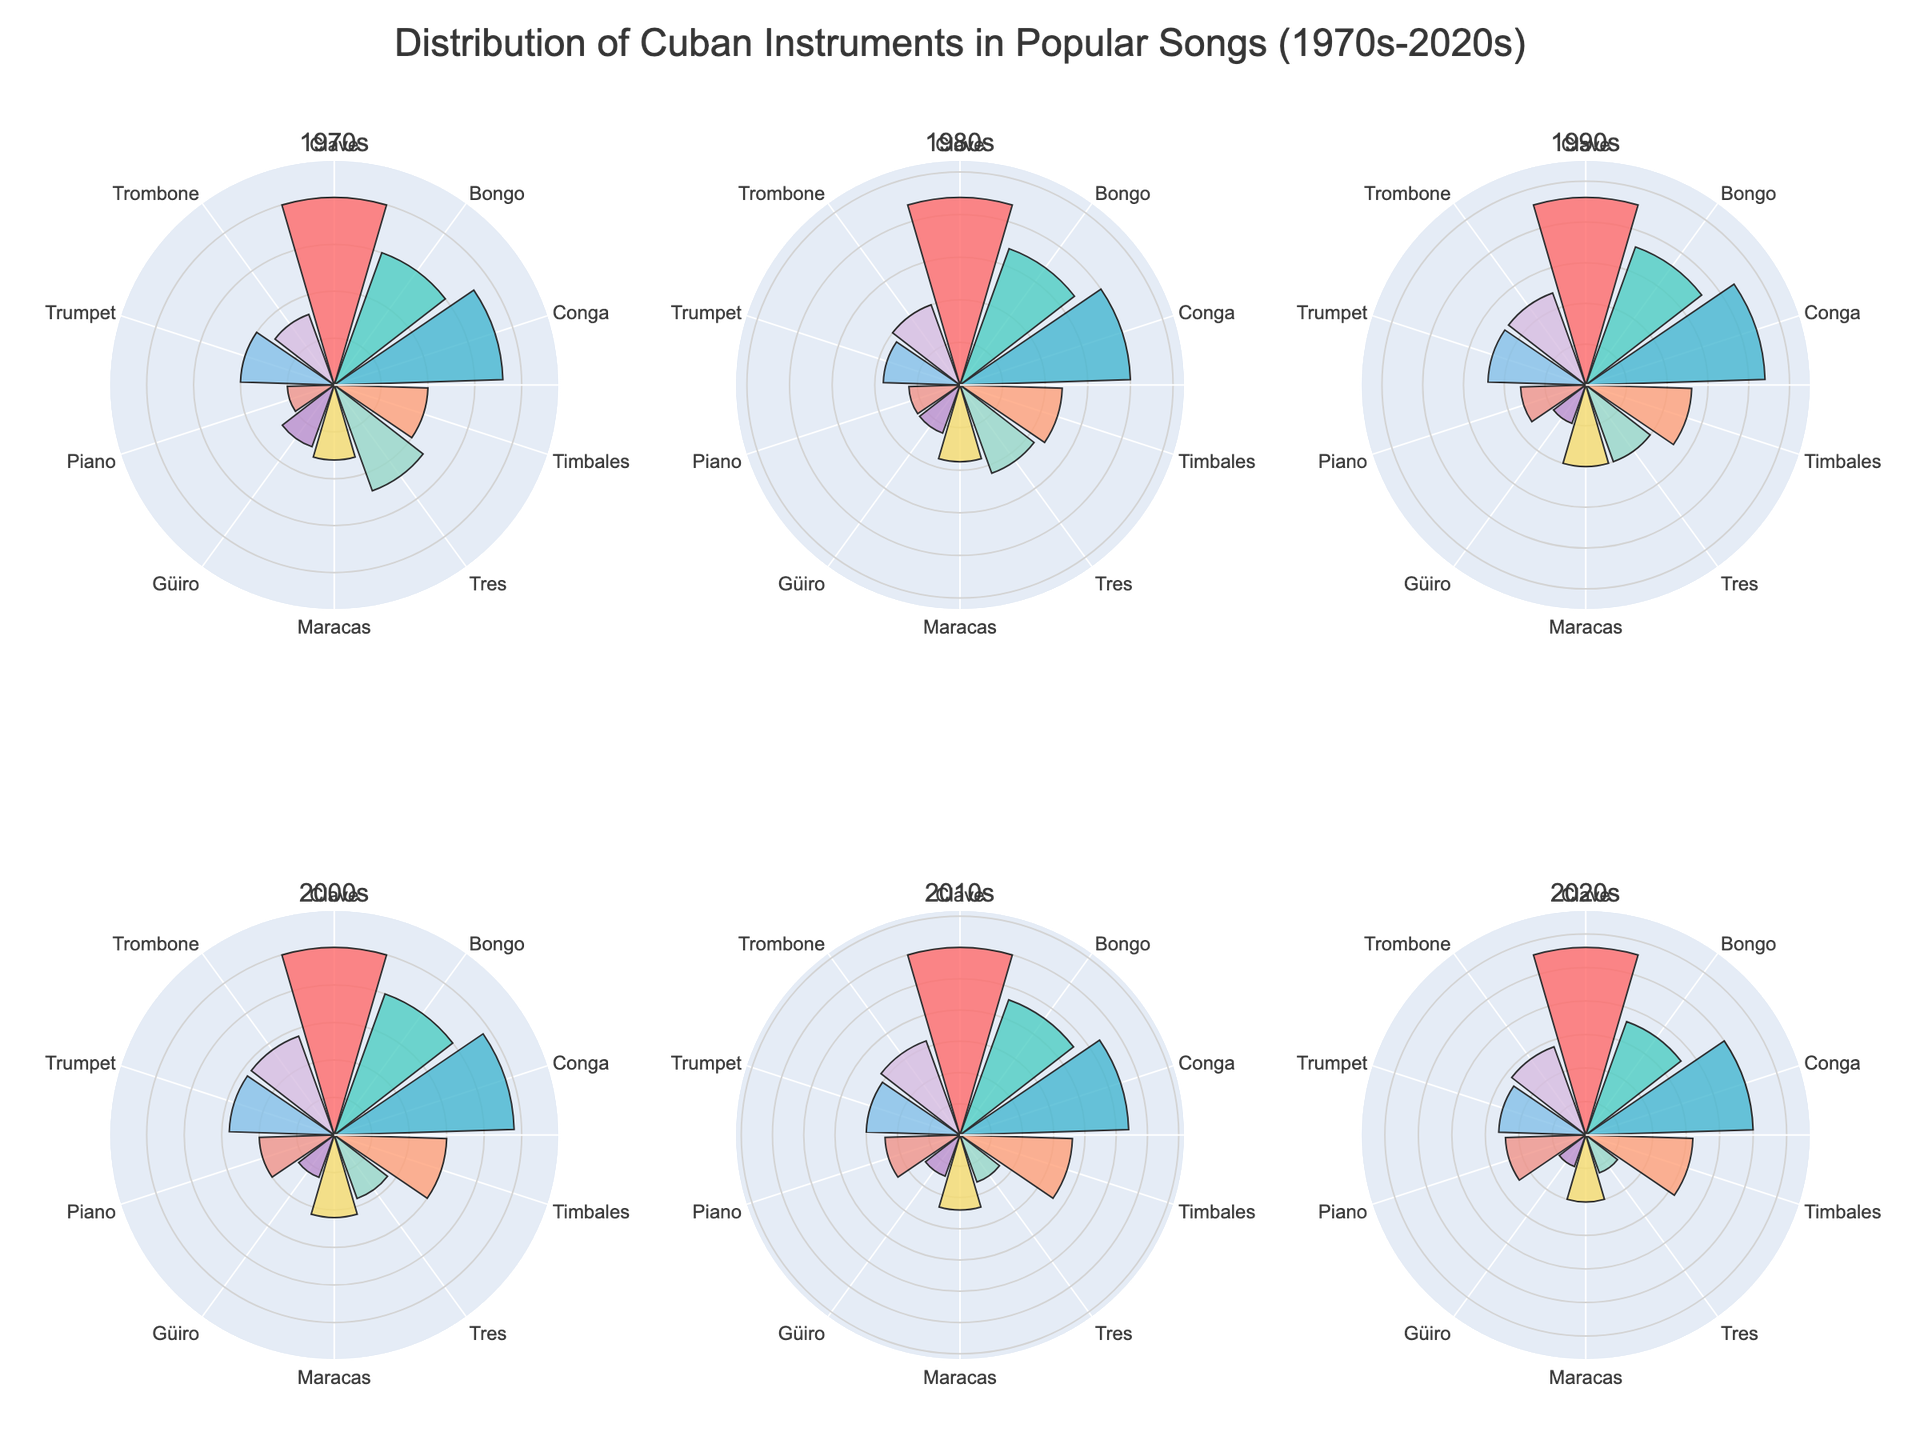What's the title of the figure? The title is usually placed at the top of the figure in a larger font size for immediate recognition. In this case, it states the context of the data.
Answer: Distribution of Cuban Instruments in Popular Songs (1970s-2020s) Which decade shows the highest usage of Clave? By looking at the heights of the bars corresponding to "Clave" across all subplots, we can identify the decade with the highest value.
Answer: 2010s What instrument showed a consistent decline in usage from the 1970s to the 2020s? By observing the trends in multiple subplots, we can see which instrument's bar heights decrease steadily across each decade.
Answer: Tres What's the average usage of Conga across the decades? Calculate the average by summing the usage values of Conga for all decades and dividing by the number of decades (18+20+22+24+27+25 = 136; 136/6 = 22.67).
Answer: 22.67 Which two decades have the same level of Maracas usage? By comparing the bar height for "Maracas" in each subplot, we can find two decades with the same value.
Answer: 2010s and 2020s How does the usage of Trombone compare between the 1980s and 2020s? Look at the heights of the bars for "Trombone" in the subplots for the 1980s and 2020s to compare them.
Answer: Higher in the 2020s Which instrument showed an increase in usage until the 2010s and then a decline in the 2020s? By examining the trends in the subplots for all instruments, identify which instrument's bar heights increased until the 2010s and then decreased in the 2020s.
Answer: Bongo What is the range of usage values for Güiro across the decades? Identify the maximum and minimum values of "Güiro" across all decades and subtract the minimum from the maximum to get the range (7 - 5 = 2).
Answer: 2 In which decade did the Trumpet usage first surpass the Timables usage? Compare the heights of bars for "Trumpet" and "Timables" for each decade until Trumpet's bar surpasses Timbales'.
Answer: 2000s 